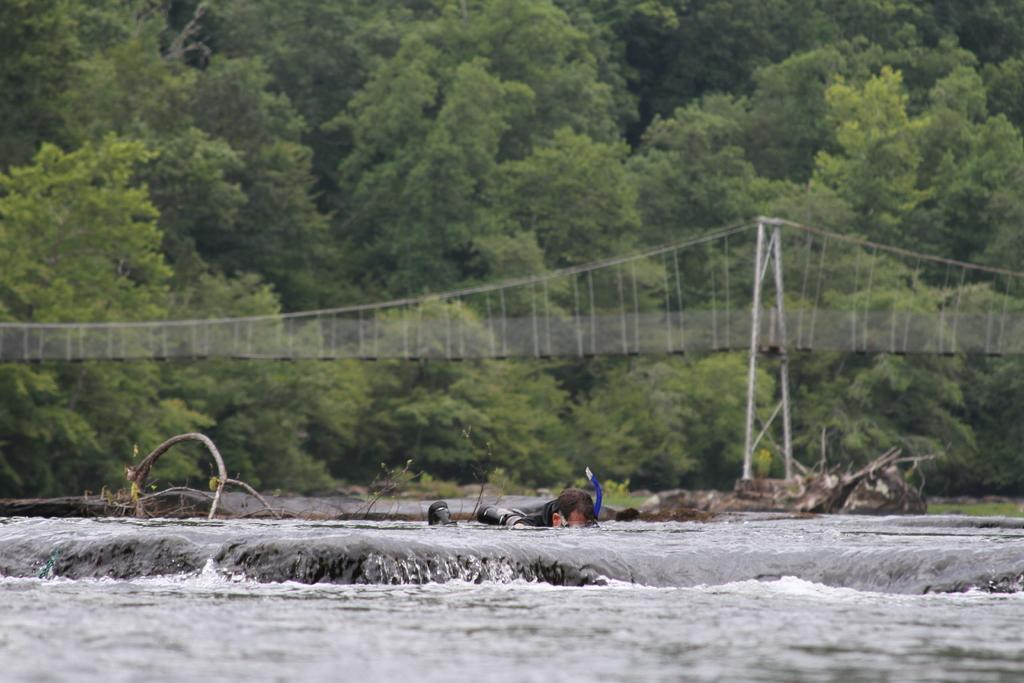What is the primary element visible in the image? There is water in the image. What can be seen partially submerged in the water? There are tree trunks in the image. What is on top of the water? There are objects on the water. How can one cross the water in the image? There is a bridge across the water. What type of vegetation is visible in the background of the image? There are trees in the background of the image. What scent can be detected from the kitten in the image? There is no kitten present in the image, so it is not possible to detect any scent. 